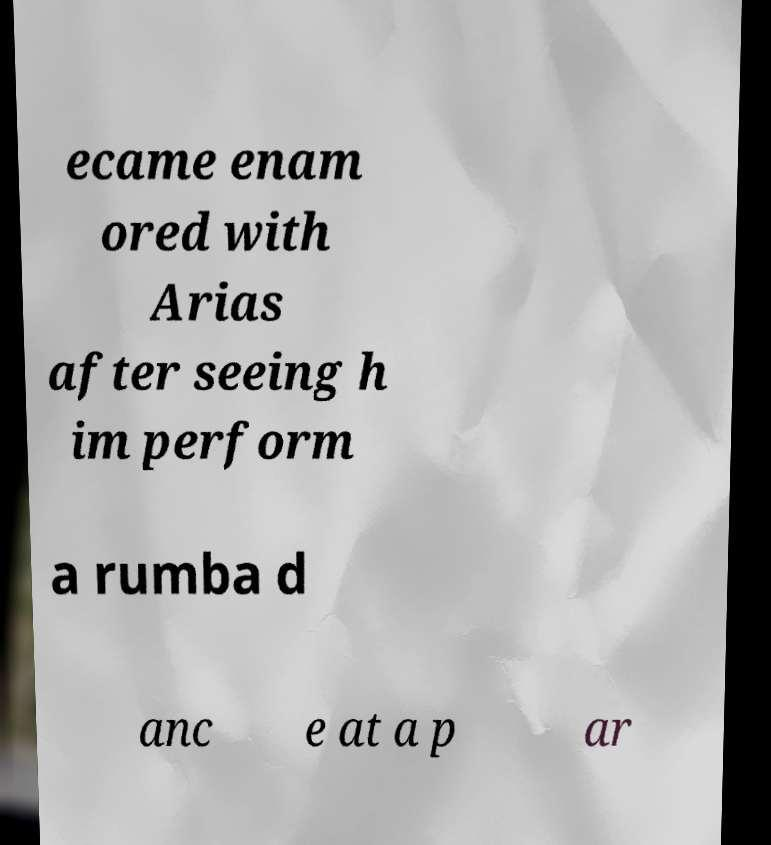For documentation purposes, I need the text within this image transcribed. Could you provide that? ecame enam ored with Arias after seeing h im perform a rumba d anc e at a p ar 